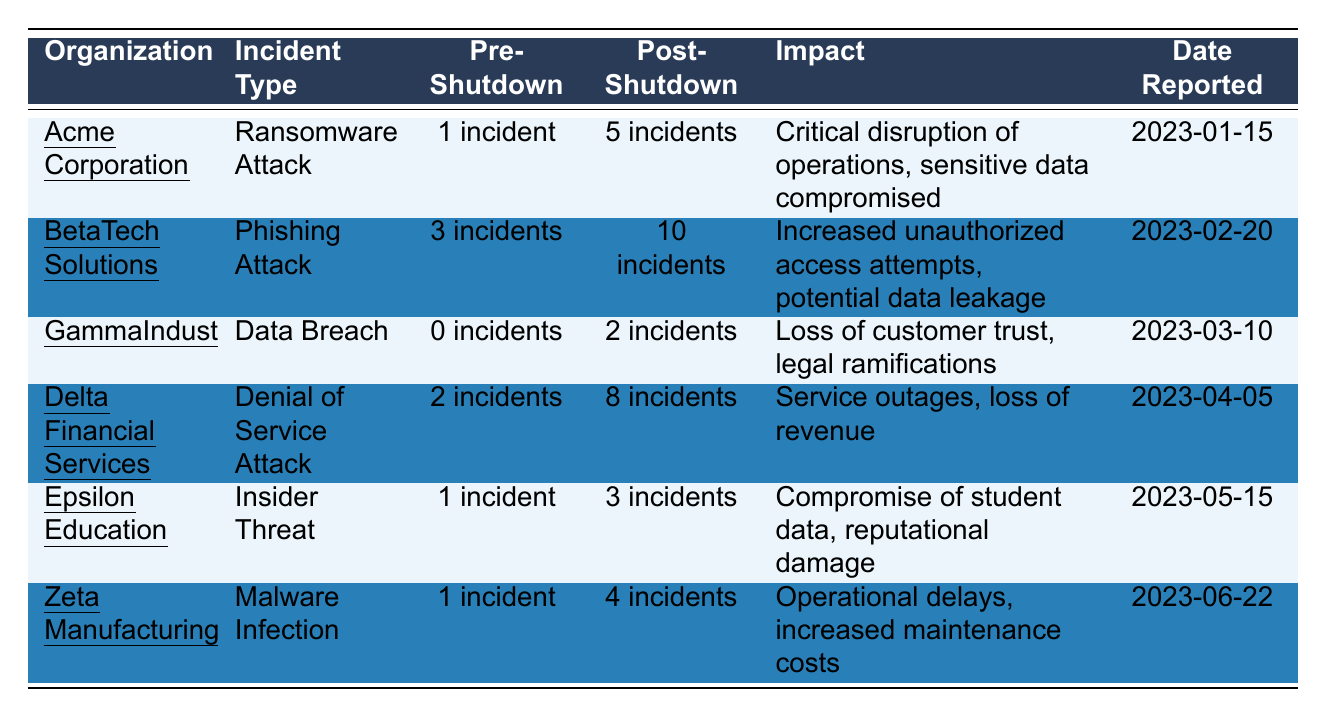What is the incident type reported by Acme Corporation? The table indicates that Acme Corporation reported a "Ransomware Attack" incident.
Answer: Ransomware Attack How many incidents were reported by BetaTech Solutions after the shutdown? According to the table, BetaTech Solutions reported "10 incidents" during the post-shutdown period.
Answer: 10 incidents Did GammaIndustries experience any incidents before the shutdown? The table states that GammaIndustries had "0 incidents" during the pre-shutdown period.
Answer: No What was the total number of incidents reported post-shutdown across all organizations? To find the total, sum the post-shutdown incidents: 5 + 10 + 2 + 8 + 3 + 4 = 32 incidents.
Answer: 32 incidents Which organization had the highest increase in incidents from pre- to post-shutdown? By comparing the differences: Acme (4), BetaTech (7), Gamma (2), Delta (6), Epsilon (2), Zeta (3). BetaTech Solutions had the highest increase with 7 incidents.
Answer: BetaTech Solutions What percentage of incidents reported post-shutdown were due to ransomware attacks? There was 1 ransomware incident pre-shutdown and 5 post-shutdown; hence it constitutes 5/32 * 100 = 15.625%.
Answer: Approximately 15.63% Is there a correlation between the type of incident and the impact reported post-shutdown? Analyzing the table shows varying impacts for each incident type, suggesting differences in severity, but a statistical correlation requires a more detailed analysis beyond this table.
Answer: No specific correlation can be determined here What is the average number of incidents reported during the pre-shutdown period? The pre-shutdown incidents are: 1, 3, 0, 2, 1, 1. The average is (1 + 3 + 0 + 2 + 1 + 1) / 6 = 1. This rounds down to 1.
Answer: 1 incident Which organization reported the earliest incident? The date reported for Acme Corporation's incident (2023-01-15) is earlier than the others, as listed in the table.
Answer: Acme Corporation How many types of incidents reported were linked to data compromise? The incidents related to data compromise in the table are "Ransomware Attack," "Insider Threat," and "Data Breach." This totals to 3 types.
Answer: 3 types 